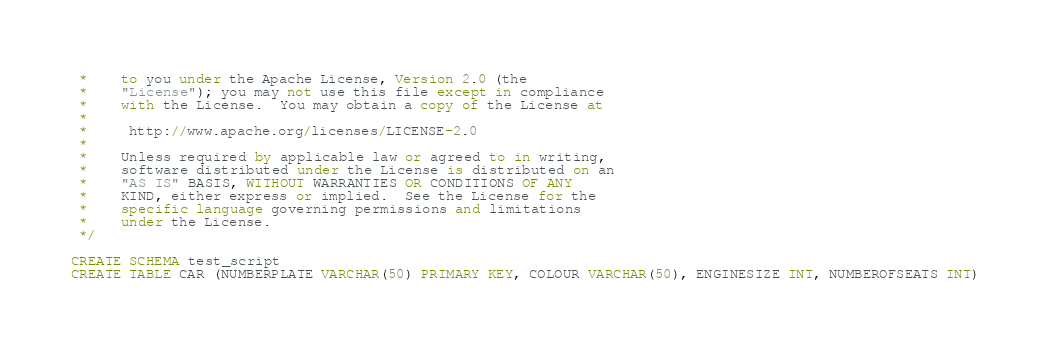<code> <loc_0><loc_0><loc_500><loc_500><_SQL_> *    to you under the Apache License, Version 2.0 (the
 *    "License"); you may not use this file except in compliance
 *    with the License.  You may obtain a copy of the License at
 *    
 *     http://www.apache.org/licenses/LICENSE-2.0
 *    
 *    Unless required by applicable law or agreed to in writing,
 *    software distributed under the License is distributed on an
 *    "AS IS" BASIS, WITHOUT WARRANTIES OR CONDITIONS OF ANY
 *    KIND, either express or implied.  See the License for the
 *    specific language governing permissions and limitations
 *    under the License.
 */

CREATE SCHEMA test_script
CREATE TABLE CAR (NUMBERPLATE VARCHAR(50) PRIMARY KEY, COLOUR VARCHAR(50), ENGINESIZE INT, NUMBEROFSEATS INT)</code> 